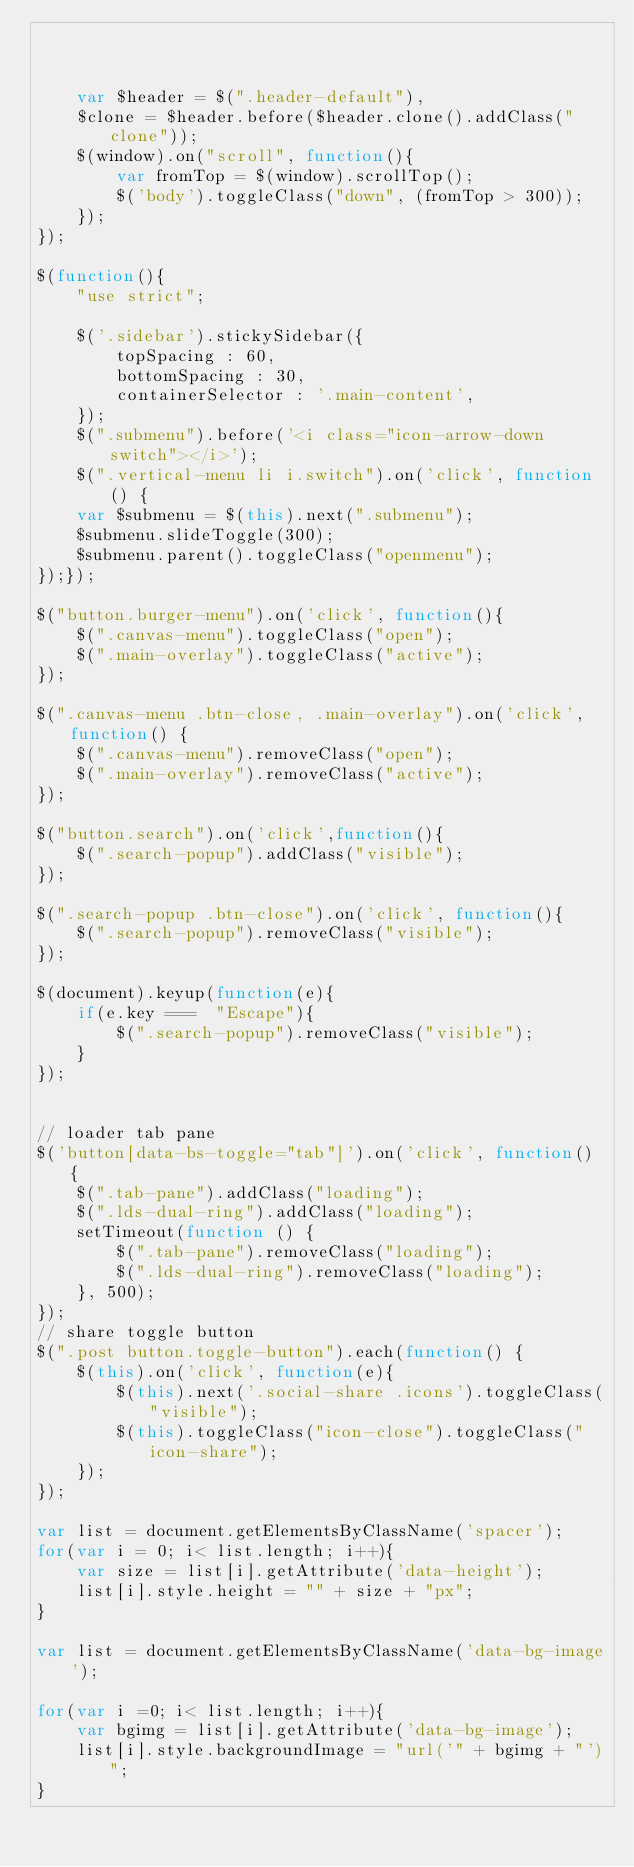Convert code to text. <code><loc_0><loc_0><loc_500><loc_500><_JavaScript_>


    var $header = $(".header-default"),
    $clone = $header.before($header.clone().addClass("clone"));
    $(window).on("scroll", function(){
        var fromTop = $(window).scrollTop();
        $('body').toggleClass("down", (fromTop > 300));
    });
});

$(function(){
    "use strict";

    $('.sidebar').stickySidebar({
        topSpacing : 60,
        bottomSpacing : 30,
        containerSelector : '.main-content',
    });
    $(".submenu").before('<i class="icon-arrow-down switch"></i>');
    $(".vertical-menu li i.switch").on('click', function() {
    var $submenu = $(this).next(".submenu");
    $submenu.slideToggle(300);
    $submenu.parent().toggleClass("openmenu");
});});

$("button.burger-menu").on('click', function(){
    $(".canvas-menu").toggleClass("open");
    $(".main-overlay").toggleClass("active");
});

$(".canvas-menu .btn-close, .main-overlay").on('click', function() {
    $(".canvas-menu").removeClass("open");
    $(".main-overlay").removeClass("active");
});

$("button.search").on('click',function(){
    $(".search-popup").addClass("visible");
});

$(".search-popup .btn-close").on('click', function(){
    $(".search-popup").removeClass("visible");
});

$(document).keyup(function(e){
    if(e.key ===  "Escape"){
        $(".search-popup").removeClass("visible");
    }
});


// loader tab pane 
$('button[data-bs-toggle="tab"]').on('click', function() {
    $(".tab-pane").addClass("loading");
    $(".lds-dual-ring").addClass("loading");
    setTimeout(function () {
        $(".tab-pane").removeClass("loading");
        $(".lds-dual-ring").removeClass("loading");
    }, 500);
});
// share toggle button 
$(".post button.toggle-button").each(function() {
    $(this).on('click', function(e){
        $(this).next('.social-share .icons').toggleClass("visible");
        $(this).toggleClass("icon-close").toggleClass("icon-share");
    });
});

var list = document.getElementsByClassName('spacer');
for(var i = 0; i< list.length; i++){
    var size = list[i].getAttribute('data-height');
    list[i].style.height = "" + size + "px";
}

var list = document.getElementsByClassName('data-bg-image');

for(var i =0; i< list.length; i++){
    var bgimg = list[i].getAttribute('data-bg-image');
    list[i].style.backgroundImage = "url('" + bgimg + "')";
}</code> 